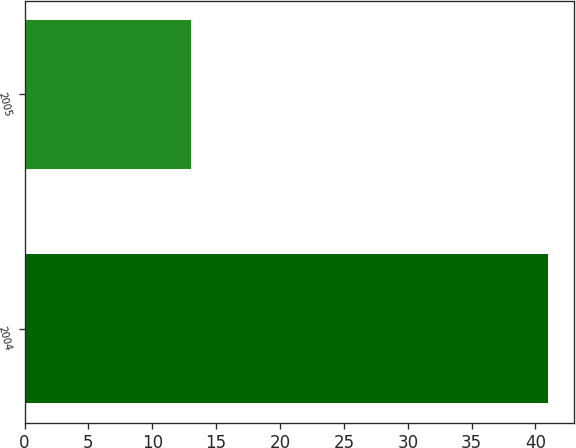Convert chart to OTSL. <chart><loc_0><loc_0><loc_500><loc_500><bar_chart><fcel>2004<fcel>2005<nl><fcel>41<fcel>13<nl></chart> 